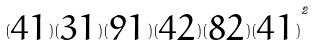<formula> <loc_0><loc_0><loc_500><loc_500>( \begin{matrix} 4 1 \end{matrix} ) ( \begin{matrix} 3 1 \end{matrix} ) ( \begin{matrix} 9 1 \end{matrix} ) ( \begin{matrix} 4 2 \end{matrix} ) ( \begin{matrix} 8 2 \end{matrix} ) { ( \begin{matrix} 4 1 \end{matrix} ) } ^ { 2 }</formula> 